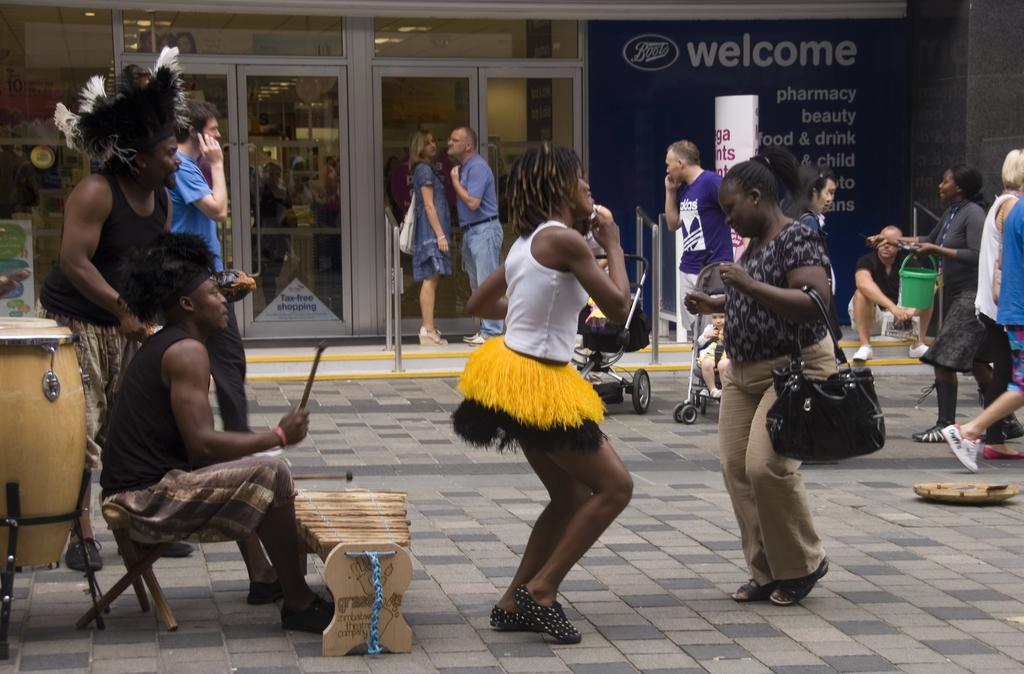What is happening in the image involving a group of people? There is a group of people in the image, and some of them are dancing. Can you describe the actions of the people in the background of the image? In the background of the image, there are people standing. How many people are involved in the dancing activity? The number of people dancing cannot be determined from the provided facts, but we know that some people in the group are dancing. What surprise did the night bring to the people in the image? There is no mention of a surprise or the night in the provided facts, so we cannot determine any surprises or the time of day from the image. 